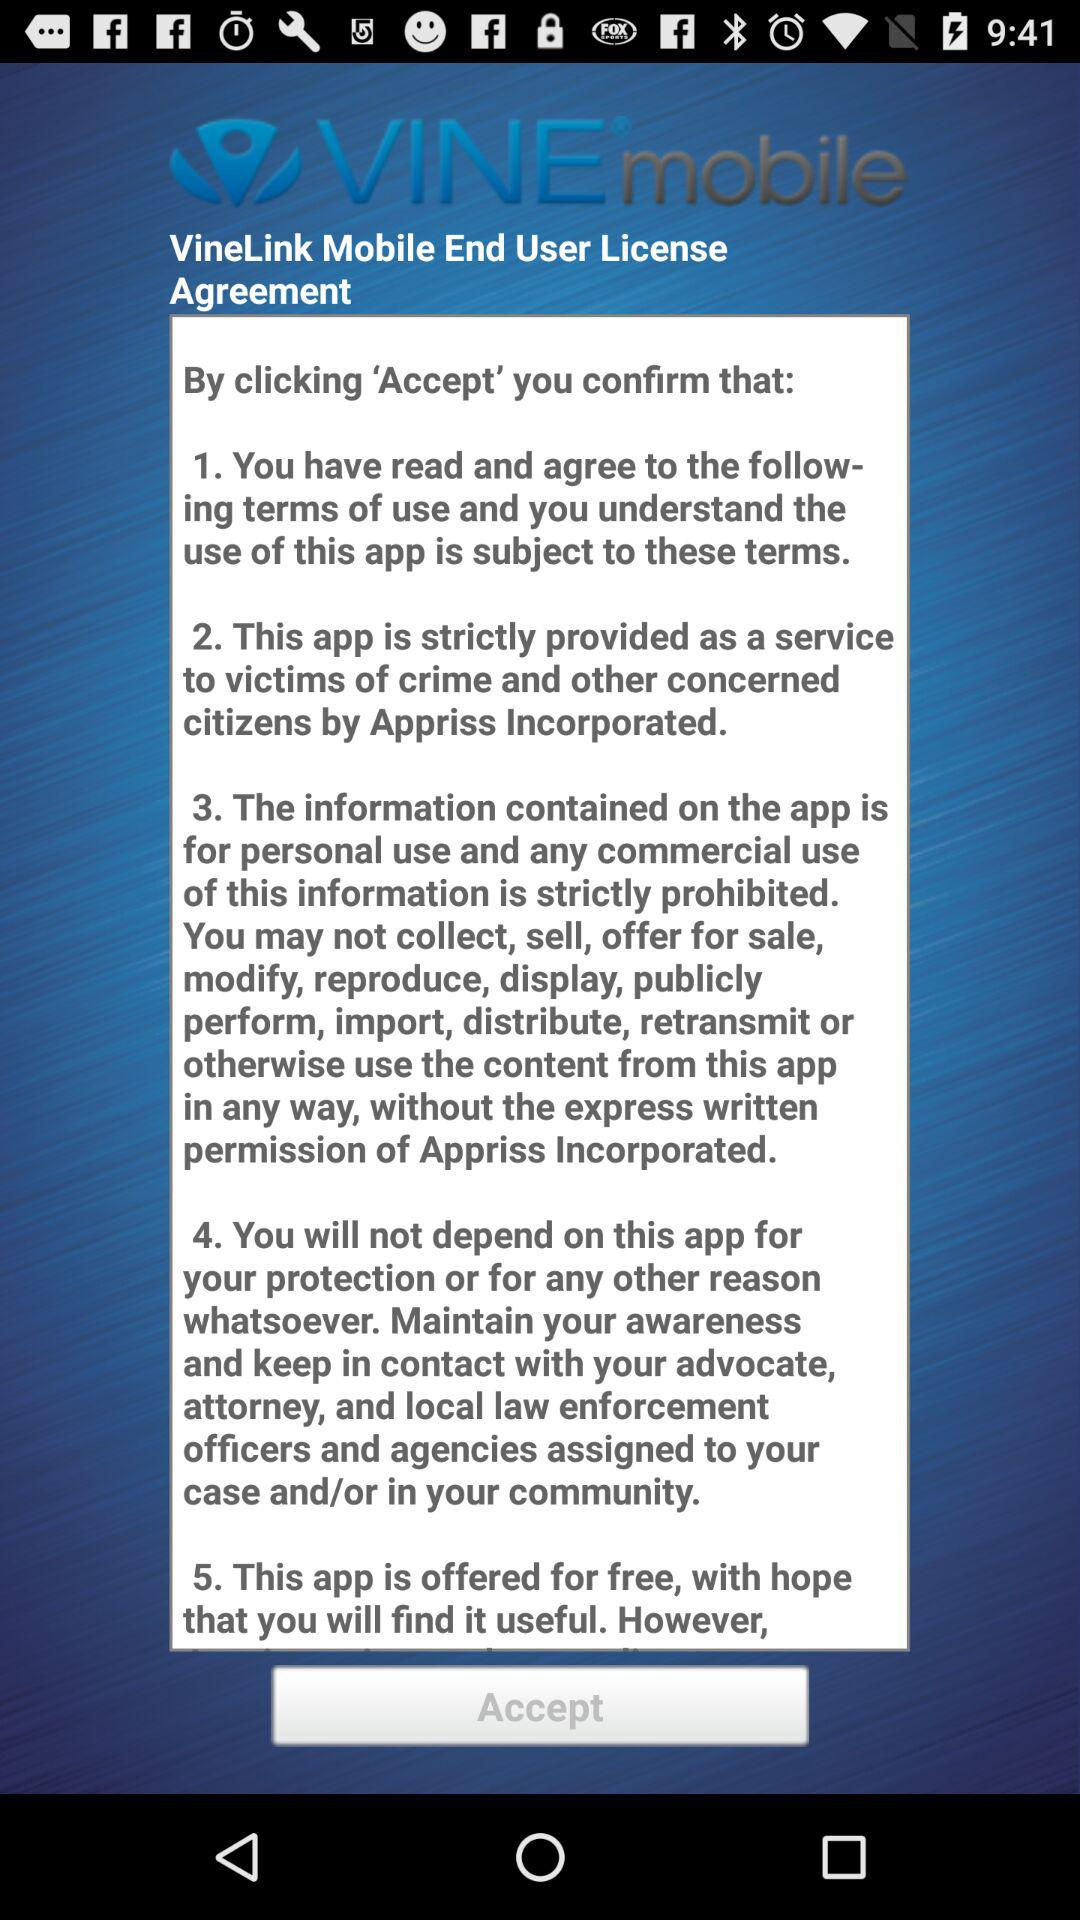How many terms of use are there?
Answer the question using a single word or phrase. 5 